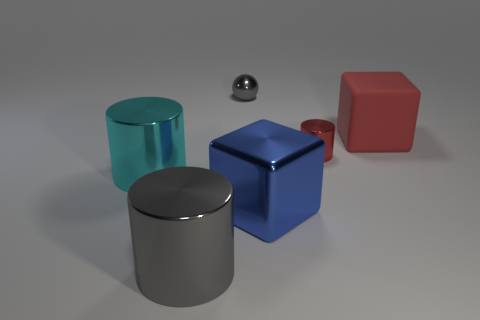There is another large cylinder that is made of the same material as the cyan cylinder; what is its color?
Ensure brevity in your answer.  Gray. Is the material of the small red object the same as the cube right of the big blue object?
Offer a very short reply. No. There is a thing that is both to the right of the blue metal block and to the left of the red rubber thing; what is its color?
Keep it short and to the point. Red. What number of blocks are matte things or red things?
Keep it short and to the point. 1. There is a big blue object; is it the same shape as the large red rubber thing that is on the right side of the gray shiny cylinder?
Give a very brief answer. Yes. How big is the thing that is both behind the red metal cylinder and to the right of the blue thing?
Your response must be concise. Large. What is the shape of the small gray object?
Your response must be concise. Sphere. There is a cylinder to the left of the large gray metal cylinder; are there any big things that are behind it?
Your answer should be compact. Yes. There is a red object that is on the left side of the matte object; how many shiny things are to the left of it?
Provide a short and direct response. 4. What is the material of the red cube that is the same size as the cyan metallic cylinder?
Provide a succinct answer. Rubber. 